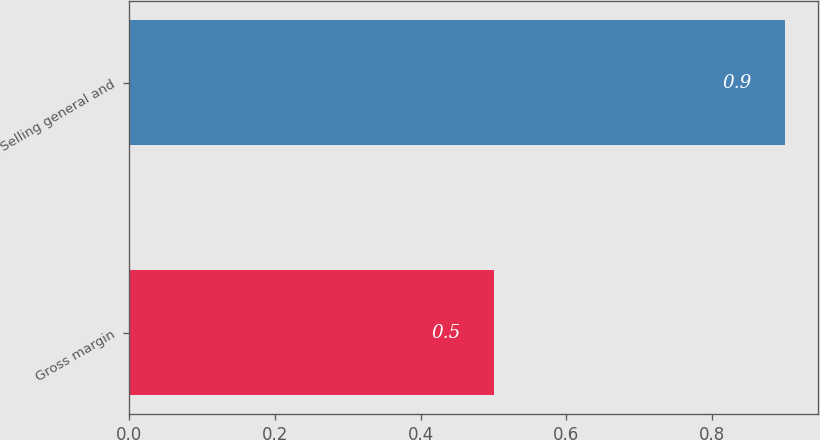<chart> <loc_0><loc_0><loc_500><loc_500><bar_chart><fcel>Gross margin<fcel>Selling general and<nl><fcel>0.5<fcel>0.9<nl></chart> 